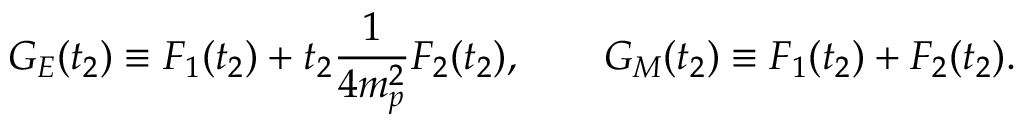Convert formula to latex. <formula><loc_0><loc_0><loc_500><loc_500>G _ { E } ( t _ { 2 } ) \equiv F _ { 1 } ( t _ { 2 } ) + t _ { 2 } \frac { 1 } { 4 m _ { p } ^ { 2 } } F _ { 2 } ( t _ { 2 } ) , \quad G _ { M } ( t _ { 2 } ) \equiv F _ { 1 } ( t _ { 2 } ) + F _ { 2 } ( t _ { 2 } ) .</formula> 